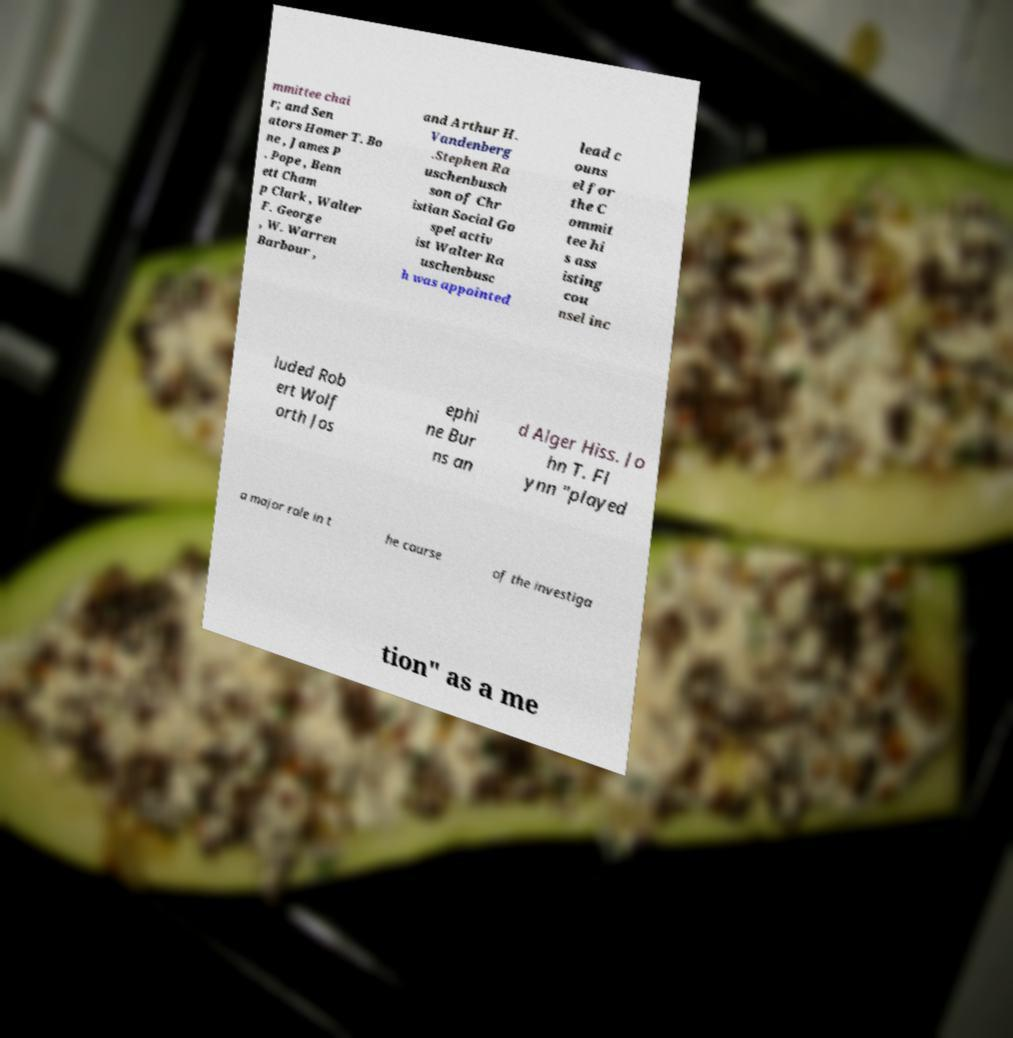There's text embedded in this image that I need extracted. Can you transcribe it verbatim? mmittee chai r; and Sen ators Homer T. Bo ne , James P . Pope , Benn ett Cham p Clark , Walter F. George , W. Warren Barbour , and Arthur H. Vandenberg .Stephen Ra uschenbusch son of Chr istian Social Go spel activ ist Walter Ra uschenbusc h was appointed lead c ouns el for the C ommit tee hi s ass isting cou nsel inc luded Rob ert Wolf orth Jos ephi ne Bur ns an d Alger Hiss. Jo hn T. Fl ynn "played a major role in t he course of the investiga tion" as a me 